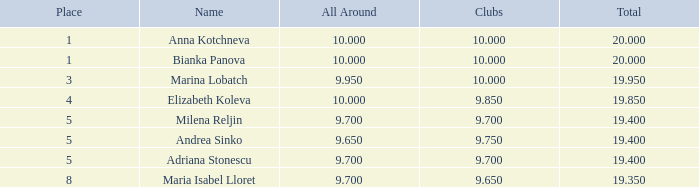What total has 10 as the clubs, with a place greater than 1? 19.95. 